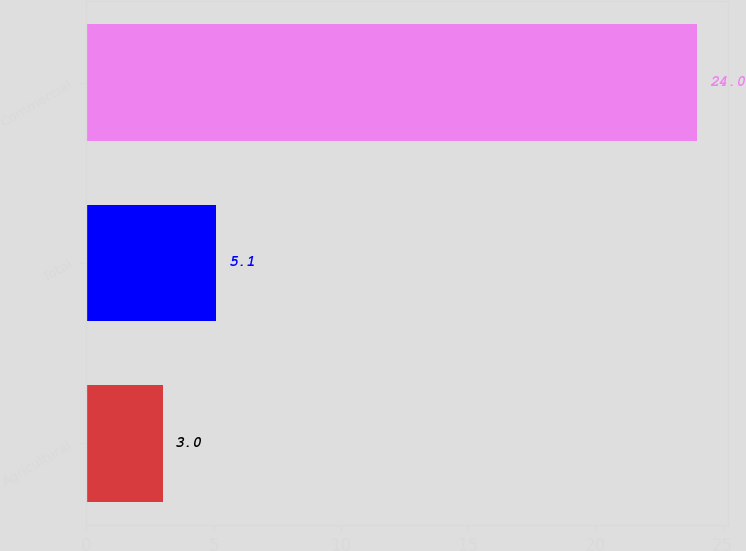<chart> <loc_0><loc_0><loc_500><loc_500><bar_chart><fcel>Agricultural<fcel>Total<fcel>Commercial<nl><fcel>3<fcel>5.1<fcel>24<nl></chart> 